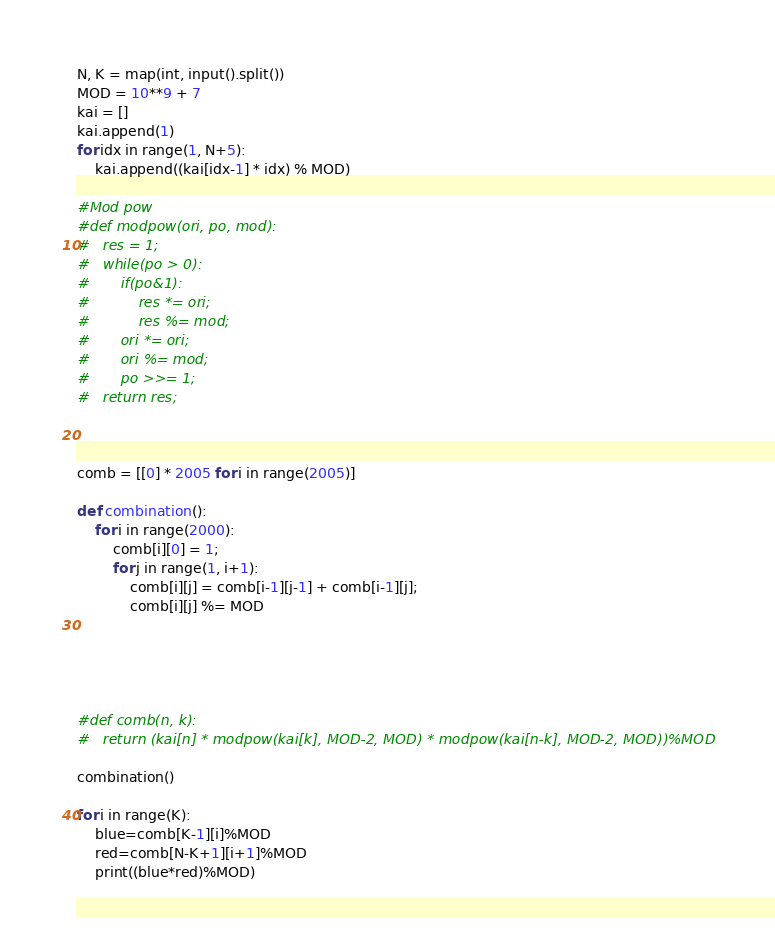<code> <loc_0><loc_0><loc_500><loc_500><_Python_>N, K = map(int, input().split())
MOD = 10**9 + 7
kai = []
kai.append(1)
for idx in range(1, N+5):
	kai.append((kai[idx-1] * idx) % MOD)

#Mod pow
#def modpow(ori, po, mod):
#	res = 1;
#	while(po > 0):
#		if(po&1):
#			res *= ori;
#			res %= mod;
#		ori *= ori;
#		ori %= mod;
#		po >>= 1;
#	return res;



comb = [[0] * 2005 for i in range(2005)]

def combination():
	for i in range(2000):
		comb[i][0] = 1;
		for j in range(1, i+1):
			comb[i][j] = comb[i-1][j-1] + comb[i-1][j];
			comb[i][j] %= MOD





#def comb(n, k):
#	return (kai[n] * modpow(kai[k], MOD-2, MOD) * modpow(kai[n-k], MOD-2, MOD))%MOD

combination()

for i in range(K):
	blue=comb[K-1][i]%MOD
	red=comb[N-K+1][i+1]%MOD
	print((blue*red)%MOD)</code> 